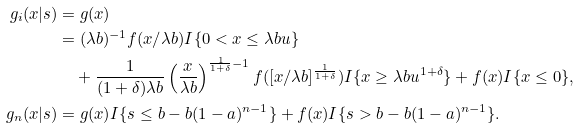<formula> <loc_0><loc_0><loc_500><loc_500>g _ { i } ( x | s ) & = g ( x ) \\ & = ( \lambda b ) ^ { - 1 } f ( x / \lambda b ) I \{ 0 < x \leq \lambda b u \} \\ & \quad + \frac { 1 } { ( 1 + \delta ) \lambda b } \left ( \frac { x } { \lambda b } \right ) ^ { \frac { 1 } { 1 + \delta } - 1 } f ( [ x / \lambda b ] ^ { \frac { 1 } { 1 + \delta } } ) I \{ x \geq \lambda b u ^ { 1 + \delta } \} + f ( x ) I \{ x \leq 0 \} , \\ g _ { n } ( x | s ) & = g ( x ) I \{ s \leq b - b ( 1 - a ) ^ { n - 1 } \} + f ( x ) I \{ s > b - b ( 1 - a ) ^ { n - 1 } \} .</formula> 